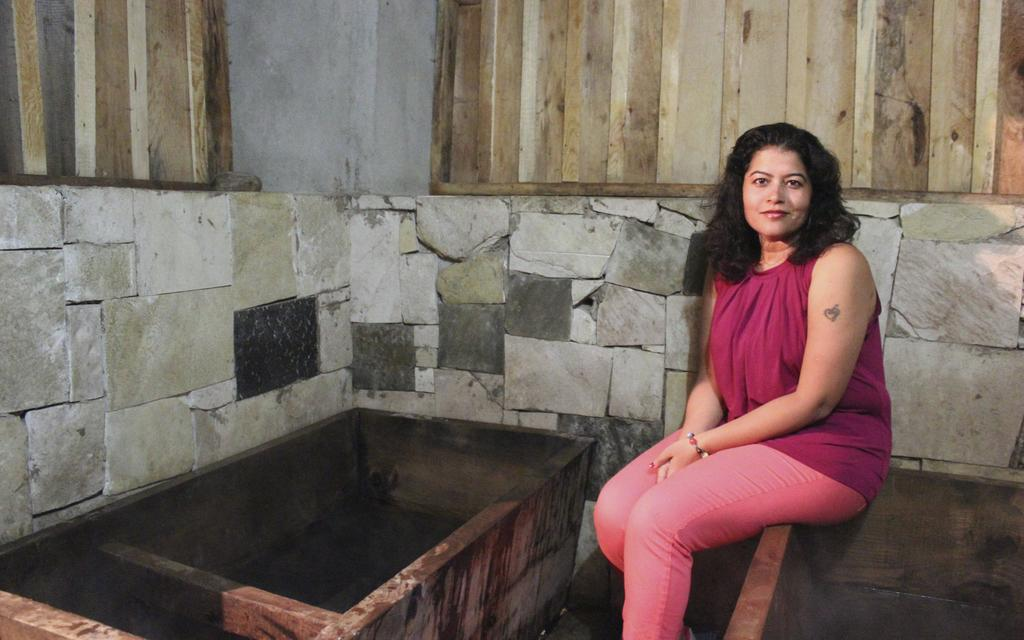Who is present in the image? There is a woman in the image. What is the woman doing in the image? The woman is sitting on a wall-like structure. What can be seen in the background of the image? There is a wall visible in the background of the image. What materials were used to construct the wall in the image? The wall is made of a combination of rocks and wood. What type of gun is the woman holding in the image? There is no gun present in the image; the woman is simply sitting on a wall-like structure. 